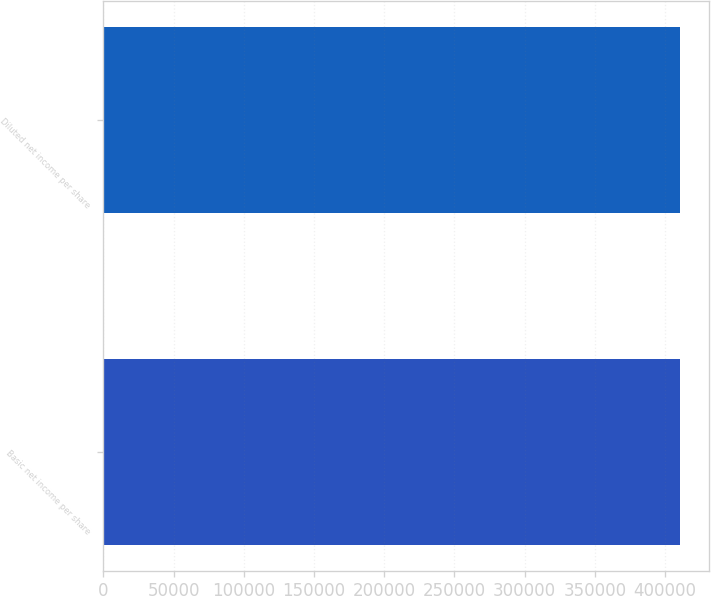Convert chart. <chart><loc_0><loc_0><loc_500><loc_500><bar_chart><fcel>Basic net income per share<fcel>Diluted net income per share<nl><fcel>410395<fcel>410395<nl></chart> 